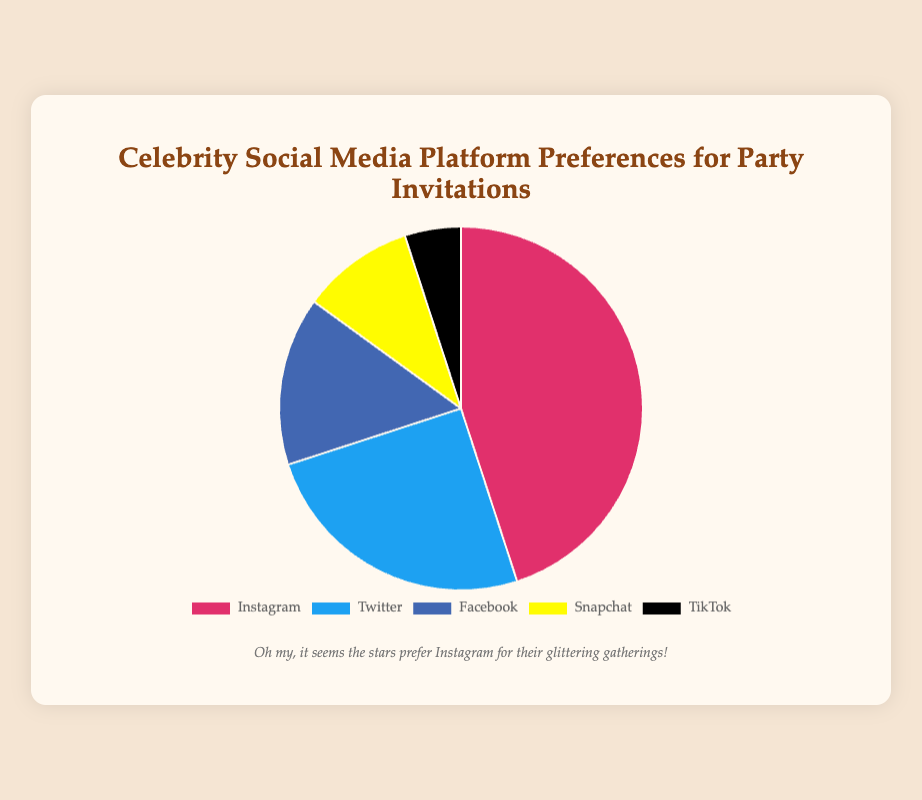what percentage of celebrities prefer Snapchat for party invitations? The pie chart shows that 10% of celebrities prefer Snapchat for party invitations.
Answer: 10% Which social media platform is the least preferred for party invitations? By looking at the pie chart, we see that TikTok, with only 5%, is the least preferred platform for party invitations among celebrities.
Answer: TikTok what is the combined percentage of celebrities who prefer Facebook and TikTok for party invitations? The pie chart indicates that 15% prefer Facebook and 5% prefer TikTok. Adding these two percentages gives us a combined total of 20%.
Answer: 20% Which platform is preferred more, Twitter or Instagram? The pie chart shows that 45% of celebrities prefer Instagram, whereas only 25% prefer Twitter. Therefore, Instagram is preferred more than Twitter.
Answer: Instagram Which color represents Facebook on the pie chart? Observing the pie chart, Facebook is represented by the color blue.
Answer: Blue How much more popular is Instagram compared to TikTok for party invitations? From the pie chart, Instagram has a 45% preference, and TikTok has a 5% preference. The difference in popularity is 45% - 5% = 40%.
Answer: 40% What is the total percentage of celebrities who prefer either Instagram or Twitter for party invitations? According to the pie chart, 45% prefer Instagram and 25% prefer Twitter. Adding these percentages, we get 45% + 25% = 70%.
Answer: 70% Among Instagram, Twitter, and Facebook, which platform is least preferred by celebrities? The pie chart indicates that Facebook is preferred by 15% of celebrities, which is less than both Instagram at 45% and Twitter at 25%. Therefore, Facebook is the least preferred among the three.
Answer: Facebook If we combine the preferences for Snapchat and TikTok, what fraction of the total do they represent? The pie chart shows that Snapchat is preferred by 10% and TikTok by 5%. Together, they represent 10% + 5% = 15% or 15/100 of the total, which simplifies to 3/20.
Answer: 3/20 